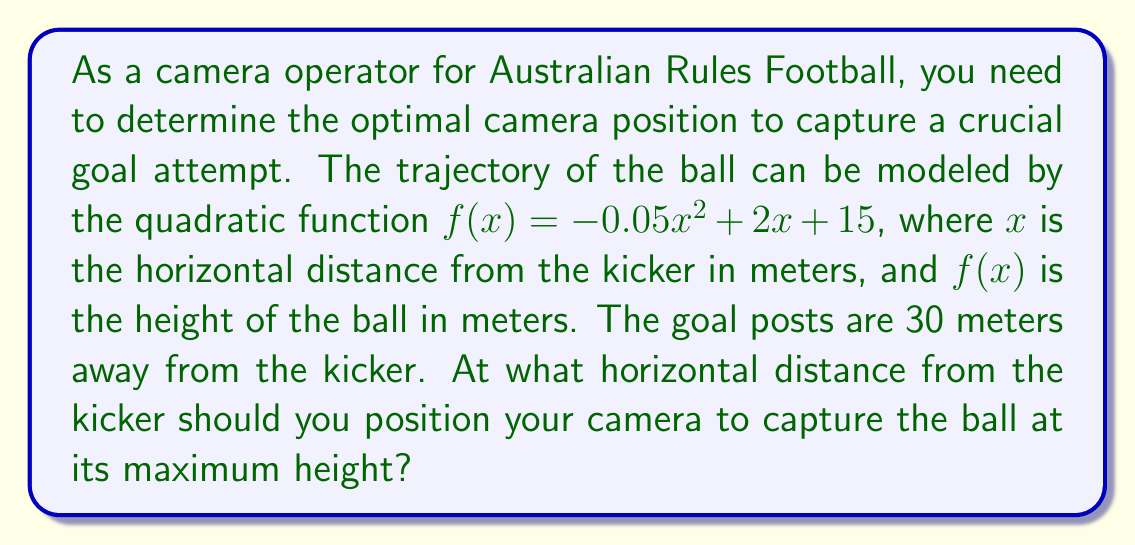Can you answer this question? To find the optimal camera position, we need to determine the x-coordinate of the vertex of the parabola, which represents the point where the ball reaches its maximum height.

For a quadratic function in the form $f(x) = ax^2 + bx + c$, the x-coordinate of the vertex is given by the formula: $x = -\frac{b}{2a}$

In this case:
$a = -0.05$
$b = 2$
$c = 15$

Substituting these values into the formula:

$x = -\frac{2}{2(-0.05)} = -\frac{2}{-0.1} = 20$

Therefore, the ball reaches its maximum height when $x = 20$ meters from the kicker.

To verify this result, we can calculate the y-coordinate of the vertex:

$f(20) = -0.05(20)^2 + 2(20) + 15$
$= -0.05(400) + 40 + 15$
$= -20 + 40 + 15$
$= 35$

So, the vertex of the parabola is at the point (20, 35).

We can also confirm that this is indeed the maximum point by checking values on either side:

$f(19) = -0.05(19)^2 + 2(19) + 15 = 34.95$
$f(21) = -0.05(21)^2 + 2(21) + 15 = 34.95$

Both of these values are less than $f(20) = 35$, confirming that x = 20 is the maximum point.
Answer: The optimal camera position to capture the ball at its maximum height is 20 meters from the kicker. 